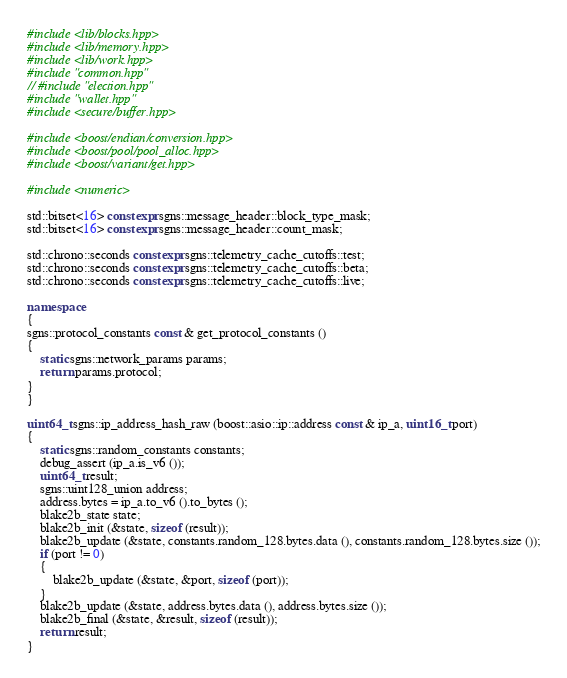<code> <loc_0><loc_0><loc_500><loc_500><_C++_>#include <lib/blocks.hpp>
#include <lib/memory.hpp>
#include <lib/work.hpp>
#include "common.hpp"
// #include "election.hpp"
#include "wallet.hpp"
#include <secure/buffer.hpp>

#include <boost/endian/conversion.hpp>
#include <boost/pool/pool_alloc.hpp>
#include <boost/variant/get.hpp>

#include <numeric>

std::bitset<16> constexpr sgns::message_header::block_type_mask;
std::bitset<16> constexpr sgns::message_header::count_mask;

std::chrono::seconds constexpr sgns::telemetry_cache_cutoffs::test;
std::chrono::seconds constexpr sgns::telemetry_cache_cutoffs::beta;
std::chrono::seconds constexpr sgns::telemetry_cache_cutoffs::live;

namespace
{
sgns::protocol_constants const & get_protocol_constants ()
{
	static sgns::network_params params;
	return params.protocol;
}
}

uint64_t sgns::ip_address_hash_raw (boost::asio::ip::address const & ip_a, uint16_t port)
{
	static sgns::random_constants constants;
	debug_assert (ip_a.is_v6 ());
	uint64_t result;
	sgns::uint128_union address;
	address.bytes = ip_a.to_v6 ().to_bytes ();
	blake2b_state state;
	blake2b_init (&state, sizeof (result));
	blake2b_update (&state, constants.random_128.bytes.data (), constants.random_128.bytes.size ());
	if (port != 0)
	{
		blake2b_update (&state, &port, sizeof (port));
	}
	blake2b_update (&state, address.bytes.data (), address.bytes.size ());
	blake2b_final (&state, &result, sizeof (result));
	return result;
}
</code> 